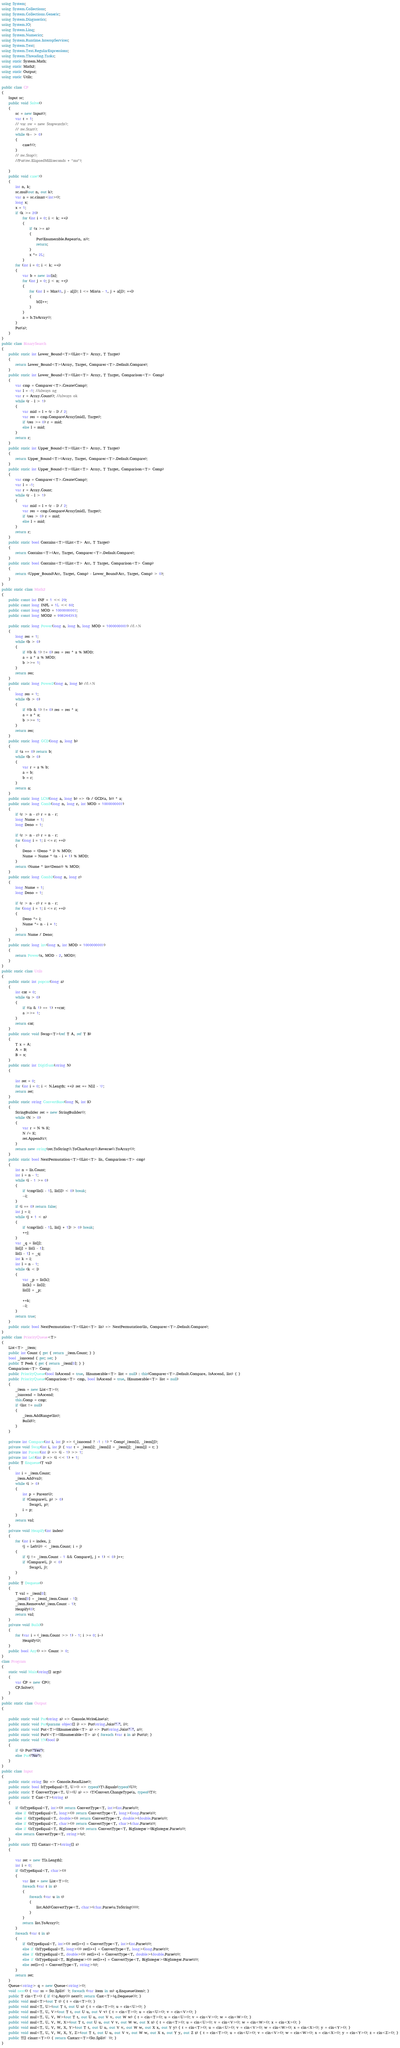<code> <loc_0><loc_0><loc_500><loc_500><_C#_>using System;
using System.Collections;
using System.Collections.Generic;
using System.Diagnostics;
using System.IO;
using System.Linq;
using System.Numerics;
using System.Runtime.InteropServices;
using System.Text;
using System.Text.RegularExpressions;
using System.Threading.Tasks;
using static System.Math;
using static Math2;
using static Output;
using static Utils;

public class CP
{
    Input sc;
    public void Solve()
    {
        sc = new Input();
        var t = 1;
        // var sw = new Stopwatch();
        // sw.Start();
        while (t-- > 0)
        {
            case1();
        }
        // sw.Stop();
        //Put(sw.ElapsedMilliseconds + "ms");

    }
    public void case1()
    {
        int n, k;
        sc.mul(out n, out k);
        var a = sc.cinarr<int>();
        long x;
        x = 1;
        if (k >= 20)
            for (int i = 0; i < k; ++i)
            {
                if (x >= n)
                {
                    Put(Enumerable.Repeat(n, n));
                    return;
                }
                x *= 2L;
            }
        for (int i = 0; i < k; ++i)
        {
            var b = new int[n];
            for (int j = 0; j < n; ++j)
            {
                for (int l = Max(0, j - a[j]); l <= Min(n - 1, j + a[j]); ++l)
                {
                    b[l]++;
                }
            }
            a = b.ToArray();
        }
        Put(a);
    }
}
public class BinarySearch
{
    public static int Lower_Bound<T>(IList<T> Array, T Target)
    {
        return Lower_Bound<T>(Array, Target, Comparer<T>.Default.Compare);
    }
    public static int Lower_Bound<T>(IList<T> Array, T Target, Comparison<T> Comp)
    {
        var cmp = Comparer<T>.Create(Comp);
        var l = -1; //always ng
        var r = Array.Count(); //always ok
        while (r - l > 1)
        {
            var mid = l + (r - l) / 2;
            var res = cmp.Compare(Array[mid], Target);
            if (res >= 0) r = mid;
            else l = mid;
        }
        return r;
    }
    public static int Upper_Bound<T>(IList<T> Array, T Target)
    {
        return Upper_Bound<T>(Array, Target, Comparer<T>.Default.Compare);
    }
    public static int Upper_Bound<T>(IList<T> Array, T Target, Comparison<T> Comp)
    {
        var cmp = Comparer<T>.Create(Comp);
        var l = -1;
        var r = Array.Count;
        while (r - l > 1)
        {
            var mid = l + (r - l) / 2;
            var res = cmp.Compare(Array[mid], Target);
            if (res > 0) r = mid;
            else l = mid;
        }
        return r;
    }
    public static bool Contains<T>(IList<T> Arr, T Target)
    {
        return Contains<T>(Arr, Target, Comparer<T>.Default.Compare);
    }
    public static bool Contains<T>(IList<T> Arr, T Target, Comparison<T> Comp)
    {
        return (Upper_Bound(Arr, Target, Comp) - Lower_Bound(Arr, Target, Comp) > 0);
    }
}
public static class Math2
{
    public const int INF = 1 << 29;
    public const long INFL = 1L << 60;
    public const long MOD = 1000000007;
    public const long MOD2 = 998244353;

    public static long Power(long a, long b, long MOD = 1000000007) //i^N
    {
        long res = 1;
        while (b > 0)
        {
            if ((b & 1) != 0) res = res * a % MOD;
            a = a * a % MOD;
            b >>= 1;
        }
        return res;
    }
    public static long Power2(long a, long b) //i^N
    {
        long res = 1;
        while (b > 0)
        {
            if ((b & 1) != 0) res = res * a;
            a = a * a;
            b >>= 1;
        }
        return res;
    }
    public static long GCD(long a, long b)
    {
        if (a == 0) return b;
        while (b > 0)
        {
            var r = a % b;
            a = b;
            b = r;
        }
        return a;
    }
    public static long LCM(long a, long b) => (b / GCD(a, b)) * a;
    public static long Comb(long n, long r, int MOD = 1000000007)
    {
        if (r > n - r) r = n - r;
        long Nume = 1;
        long Deno = 1;

        if (r > n - r) r = n - r;
        for (long i = 1; i <= r; ++i)
        {
            Deno = (Deno * i) % MOD;
            Nume = Nume * (n - i + 1) % MOD;
        }
        return (Nume * inv(Deno)) % MOD;
    }
    public static long Comb2(long n, long r)
    {
        long Nume = 1;
        long Deno = 1;

        if (r > n - r) r = n - r;
        for (long i = 1; i <= r; ++i)
        {
            Deno *= i;
            Nume *= n - i + 1;
        }
        return Nume / Deno;
    }
    public static long inv(long x, int MOD = 1000000007)
    {
        return Power(x, MOD - 2, MOD);
    }
}
public static class Utils
{
    public static int popcnt(long a)
    {
        int cnt = 0;
        while (a > 0)
        {
            if ((a & 1) == 1) ++cnt;
            a >>= 1;
        }
        return cnt;
    }
    public static void Swap<T>(ref T A, ref T B)
    {
        T x = A;
        A = B;
        B = x;
    }
    public static int DigitSum(string N)
    {

        int ret = 0;
        for (int i = 0; i < N.Length; ++i) ret += N[i] - '0';
        return ret;
    }
    public static string ConvertBase(long N, int K)
    {
        StringBuilder ret = new StringBuilder();
        while (N > 0)
        {
            var r = N % K;
            N /= K;
            ret.Append(r);
        }
        return new string(ret.ToString().ToCharArray().Reverse().ToArray());
    }
    public static bool NextPermutation<T>(IList<T> lis, Comparison<T> cmp)
    {
        int n = lis.Count;
        int i = n - 1;
        while (i - 1 >= 0)
        {
            if (cmp(lis[i - 1], lis[i]) < 0) break;
            --i;
        }
        if (i == 0) return false;
        int j = i;
        while (j + 1 < n)
        {
            if (cmp(lis[i - 1], lis[j + 1]) > 0) break;
            ++j;
        }
        var _q = lis[j];
        lis[j] = lis[i - 1];
        lis[i - 1] = _q;
        int k = i;
        int l = n - 1;
        while (k < l)
        {
            var _p = lis[k];
            lis[k] = lis[l];
            lis[l] = _p;

            ++k;
            --l;
        }
        return true;
    }
    public static bool NextPermutation<T>(IList<T> lis) => NextPermutation(lis, Comparer<T>.Default.Compare);
}
public class PriorityQueue<T>
{
    List<T> _item;
    public int Count { get { return _item.Count; } }
    bool _isascend { get; set; }
    public T Peek { get { return _item[0]; } }
    Comparison<T> Comp;
    public PriorityQueue(bool IsAscend = true, IEnumerable<T> list = null) : this(Comparer<T>.Default.Compare, IsAscend, list) { }
    public PriorityQueue(Comparison<T> cmp, bool IsAscend = true, IEnumerable<T> list = null)
    {
        _item = new List<T>();
        _isascend = IsAscend;
        this.Comp = cmp;
        if (list != null)
        {
            _item.AddRange(list);
            Build();
        }
    }

    private int Compare(int i, int j) => (_isascend ? -1 : 1) * Comp(_item[i], _item[j]);
    private void Swap(int i, int j) { var t = _item[i]; _item[i] = _item[j]; _item[j] = t; }
    private int Parent(int i) => (i - 1) >> 1;
    private int Left(int i) => (i << 1) + 1;
    public T Enqueue(T val)
    {
        int i = _item.Count;
        _item.Add(val);
        while (i > 0)
        {
            int p = Parent(i);
            if (Compare(i, p) > 0)
                Swap(i, p);
            i = p;
        }
        return val;
    }
    private void Heapify(int index)
    {
        for (int i = index, j;
            (j = Left(i)) < _item.Count; i = j)
        {
            if (j != _item.Count - 1 && Compare(j, j + 1) < 0) j++;
            if (Compare(i, j) < 0)
                Swap(i, j);
        }
    }
    public T Dequeue()
    {
        T val = _item[0];
        _item[0] = _item[_item.Count - 1];
        _item.RemoveAt(_item.Count - 1);
        Heapify(0);
        return val;
    }
    private void Build()
    {
        for (var i = (_item.Count >> 1) - 1; i >= 0; i--)
            Heapify(i);
    }
    public bool Any() => Count > 0;
}
class Program
{
    static void Main(string[] args)
    {
        var CP = new CP();
        CP.Solve();
    }
}
public static class Output
{

    public static void Put(string a) => Console.WriteLine(a);
    public static void Put(params object[] i) => Put(string.Join(" ", i));
    public static void Put<T>(IEnumerable<T> a) => Put(string.Join(" ", a));
    public static void PutV<T>(IEnumerable<T> a) { foreach (var z in a) Put(z); }
    public static void YN(bool i)
    {
        if (i) Put("Yes");
        else Put("No");
    }
}
public class Input
{
    public static string Str => Console.ReadLine();
    public static bool IsTypeEqual<T, U>() => typeof(T).Equals(typeof(U));
    public static T ConvertType<T, U>(U a) => (T)Convert.ChangeType(a, typeof(T));
    public static T Cast<T>(string s)
    {
        if (IsTypeEqual<T, int>()) return ConvertType<T, int>(int.Parse(s));
        else if (IsTypeEqual<T, long>()) return ConvertType<T, long>(long.Parse(s));
        else if (IsTypeEqual<T, double>()) return ConvertType<T, double>(double.Parse(s));
        else if (IsTypeEqual<T, char>()) return ConvertType<T, char>(char.Parse(s));
        else if (IsTypeEqual<T, BigInteger>()) return ConvertType<T, BigInteger>(BigInteger.Parse(s));
        else return ConvertType<T, string>(s);
    }
    public static T[] Castarr<T>(string[] s)
    {

        var ret = new T[s.Length];
        int i = 0;
        if (IsTypeEqual<T, char>())
        {
            var list = new List<T>();
            foreach (var t in s)
            {
                foreach (var u in t)
                {
                    list.Add(ConvertType<T, char>(char.Parse(u.ToString())));
                }
            }
            return list.ToArray();
        }
        foreach (var t in s)
        {
            if (IsTypeEqual<T, int>()) ret[i++] = ConvertType<T, int>(int.Parse(t));
            else if (IsTypeEqual<T, long>()) ret[i++] = ConvertType<T, long>(long.Parse(t));
            else if (IsTypeEqual<T, double>()) ret[i++] = ConvertType<T, double>(double.Parse(t));
            else if (IsTypeEqual<T, BigInteger>()) ret[i++] = ConvertType<T, BigInteger>(BigInteger.Parse(t));
            else ret[i++] = ConvertType<T, string>(t);
        }
        return ret;
    }
    Queue<string> q = new Queue<string>();
    void next() { var ss = Str.Split(' '); foreach (var item in ss) q.Enqueue(item); }
    public T cin<T>() { if (!q.Any()) next(); return Cast<T>(q.Dequeue()); }
    public void mul<T>(out T t) { t = cin<T>(); }
    public void mul<T, U>(out T t, out U u) { t = cin<T>(); u = cin<U>(); }
    public void mul<T, U, V>(out T t, out U u, out V v) { t = cin<T>(); u = cin<U>(); v = cin<V>(); }
    public void mul<T, U, V, W>(out T t, out U u, out V v, out W w) { t = cin<T>(); u = cin<U>(); v = cin<V>(); w = cin<W>(); }
    public void mul<T, U, V, W, X>(out T t, out U u, out V v, out W w, out X x) { t = cin<T>(); u = cin<U>(); v = cin<V>(); w = cin<W>(); x = cin<X>(); }
    public void mul<T, U, V, W, X, Y>(out T t, out U u, out V v, out W w, out X x, out Y y) { t = cin<T>(); u = cin<U>(); v = cin<V>(); w = cin<W>(); x = cin<X>(); y = cin<Y>(); }
    public void mul<T, U, V, W, X, Y, Z>(out T t, out U u, out V v, out W w, out X x, out Y y, out Z z) { t = cin<T>(); u = cin<U>(); v = cin<V>(); w = cin<W>(); x = cin<X>(); y = cin<Y>(); z = cin<Z>(); }
    public T[] cinarr<T>() { return Castarr<T>(Str.Split(' ')); }
}</code> 